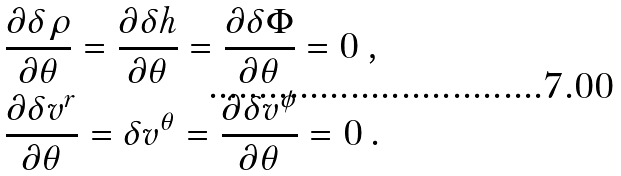<formula> <loc_0><loc_0><loc_500><loc_500>& \frac { \partial \delta \rho } { \partial \theta } = \frac { \partial \delta h } { \partial \theta } = \frac { \partial \delta \Phi } { \partial \theta } = 0 \, , \\ & \frac { \partial \delta v ^ { r } } { \partial \theta } = \delta v ^ { \theta } = \frac { \partial \delta v ^ { \phi } } { \partial \theta } = 0 \, .</formula> 